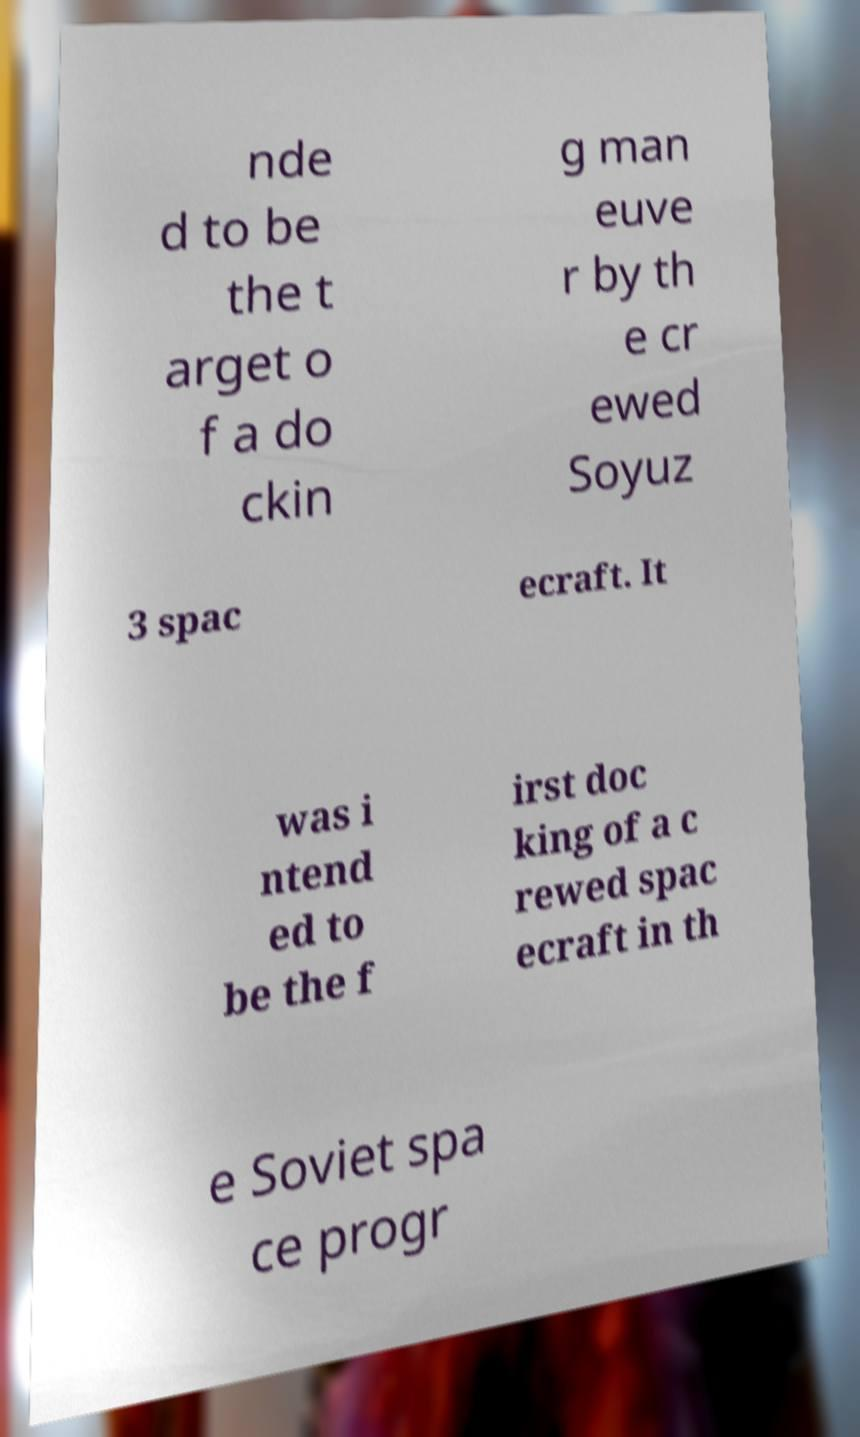There's text embedded in this image that I need extracted. Can you transcribe it verbatim? nde d to be the t arget o f a do ckin g man euve r by th e cr ewed Soyuz 3 spac ecraft. It was i ntend ed to be the f irst doc king of a c rewed spac ecraft in th e Soviet spa ce progr 